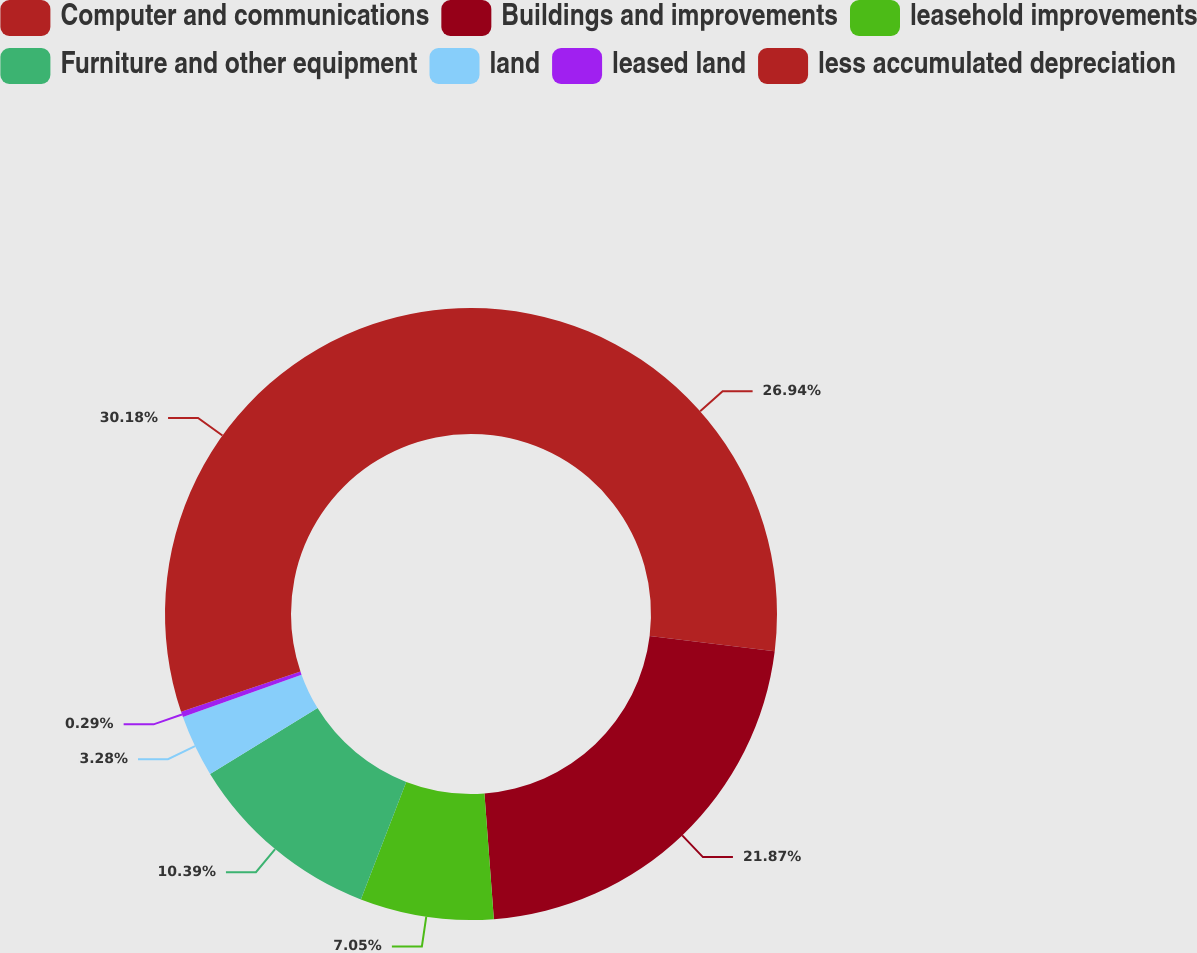<chart> <loc_0><loc_0><loc_500><loc_500><pie_chart><fcel>Computer and communications<fcel>Buildings and improvements<fcel>leasehold improvements<fcel>Furniture and other equipment<fcel>land<fcel>leased land<fcel>less accumulated depreciation<nl><fcel>26.94%<fcel>21.87%<fcel>7.05%<fcel>10.39%<fcel>3.28%<fcel>0.29%<fcel>30.18%<nl></chart> 